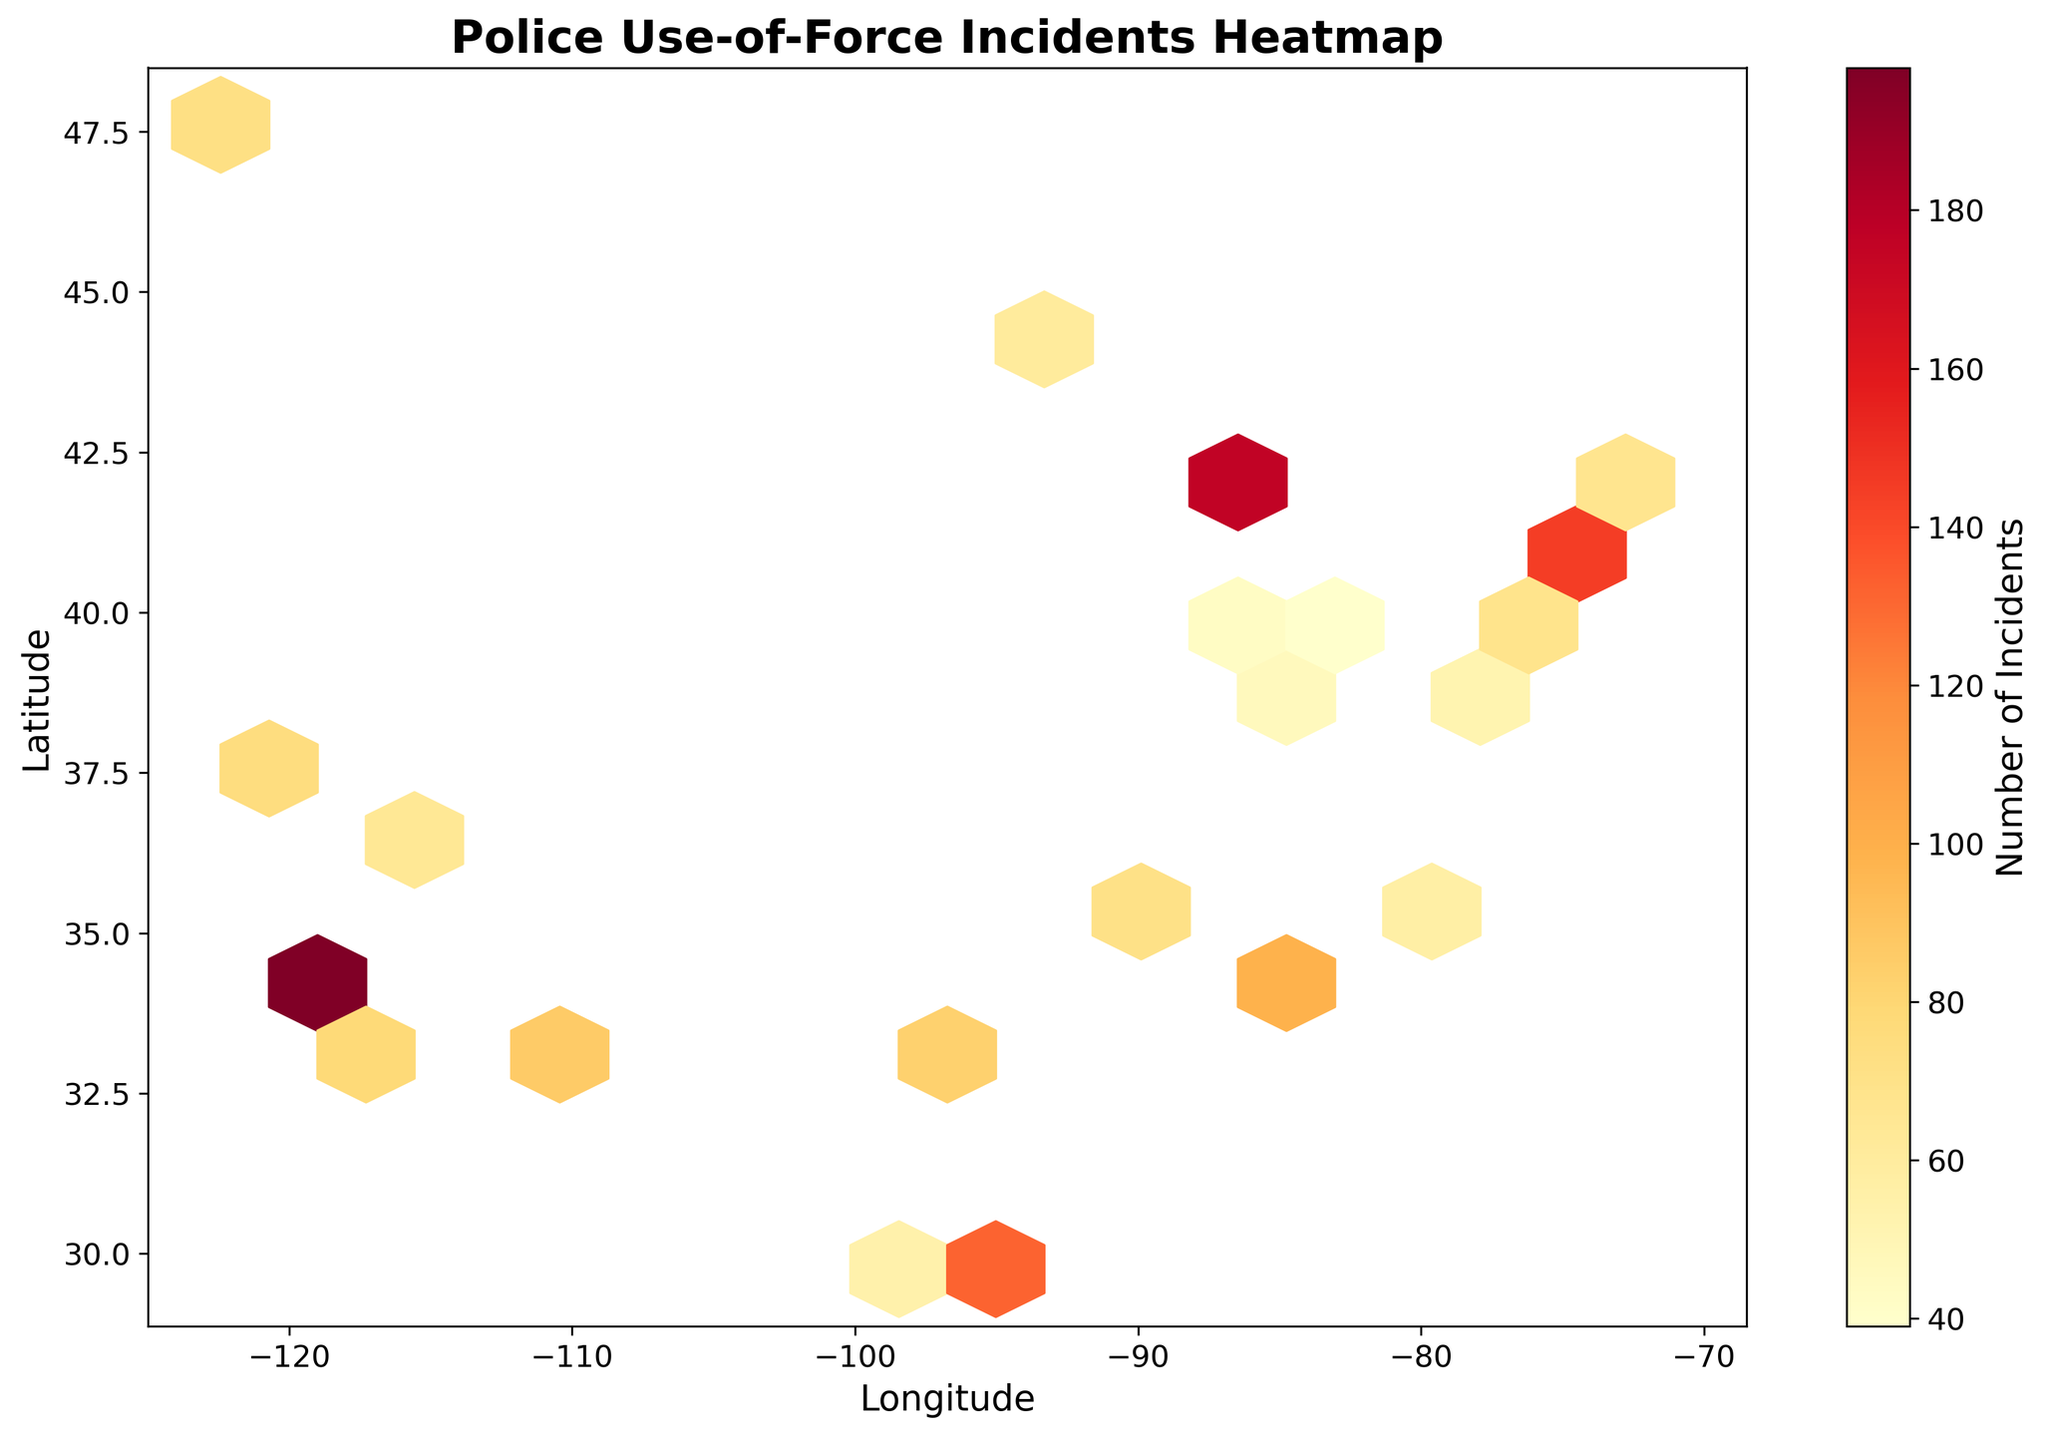What is the title of the plot? The title of the plot is usually displayed at the top center of the figure. In this case, it should read "Police Use-of-Force Incidents Heatmap".
Answer: Police Use-of-Force Incidents Heatmap What does the color intensity represent in the plot? In a hexbin plot, the color intensity often represents the magnitude of a variable. Here, darker colors indicate higher numbers of incidents, which can be confirmed by the colorbar on the plot.
Answer: Number of Incidents Which geographic region appears to have the highest concentration of use-of-force incidents? To determine this, look for the area with the darkest shade in the plot. The highest concentration seems to be around the latitude and longitude coordinates approximately matching Los Angeles (-118.2437, 34.0522).
Answer: Los Angeles What are the units for the x-axis and y-axis? Refer to the axis labels to identify the units. The x-axis is labeled "Longitude" and the y-axis is labeled "Latitude," which are standard units for geographic coordinates.
Answer: Longitude and Latitude How many bins had at least one incident? To answer this, check the color bar and the hexbin plot. Bins with at least one incident will show some color intensity. The exact count can be made visually by grouping the hexagons with color. Let’s approximate visually that most of the hexagons have some color except for a few. For a precise answer, count the colored hexagons.
Answer: Approximately most bins except a few What is the range of incident numbers shown in the color bar? Check the labels on the color bar for the minimum and maximum number of incidents. The range appears to go from a minimum of 1 incident to a maximum determined by the highest color gradient.
Answer: 1 to 198 Which city, among the ones with data, has the fewest incidents? From the dataset, cities are plotted, look for the city with the smallest color intensity. Indianapolis (39.7684, -86.1581) has only 43 incidents, which appears to be the fewest.
Answer: Indianapolis How does the eastern concentration of use-of-force incidents compare to the western concentration? Visually compare both sides of the plot. The western side, especially around Los Angeles and other major western cities, shows darker shades than the eastern side, indicating a higher concentration out west.
Answer: Higher in the west than the east Is there a noticeable difference in incidents between major coastal and inland cities? Compare the color intensities of coastal cities like New York, Los Angeles, and San Francisco to inland cities like Chicago and Dallas. Coastal cities generally show higher concentrations as evidenced by darker shades.
Answer: Coastal cities have higher incidents What insights can be drawn about regional patterns of police use-of-force incidents from this plot? Analyzing the shading and concentrations in the plot, main insights include higher incidents in major cities, especially in the west and coastal areas, and lower concentrations in less populated regions. This can highlight areas needing more focused reforms or resources.
Answer: Higher in major cities, most prominent on the west and coasts 